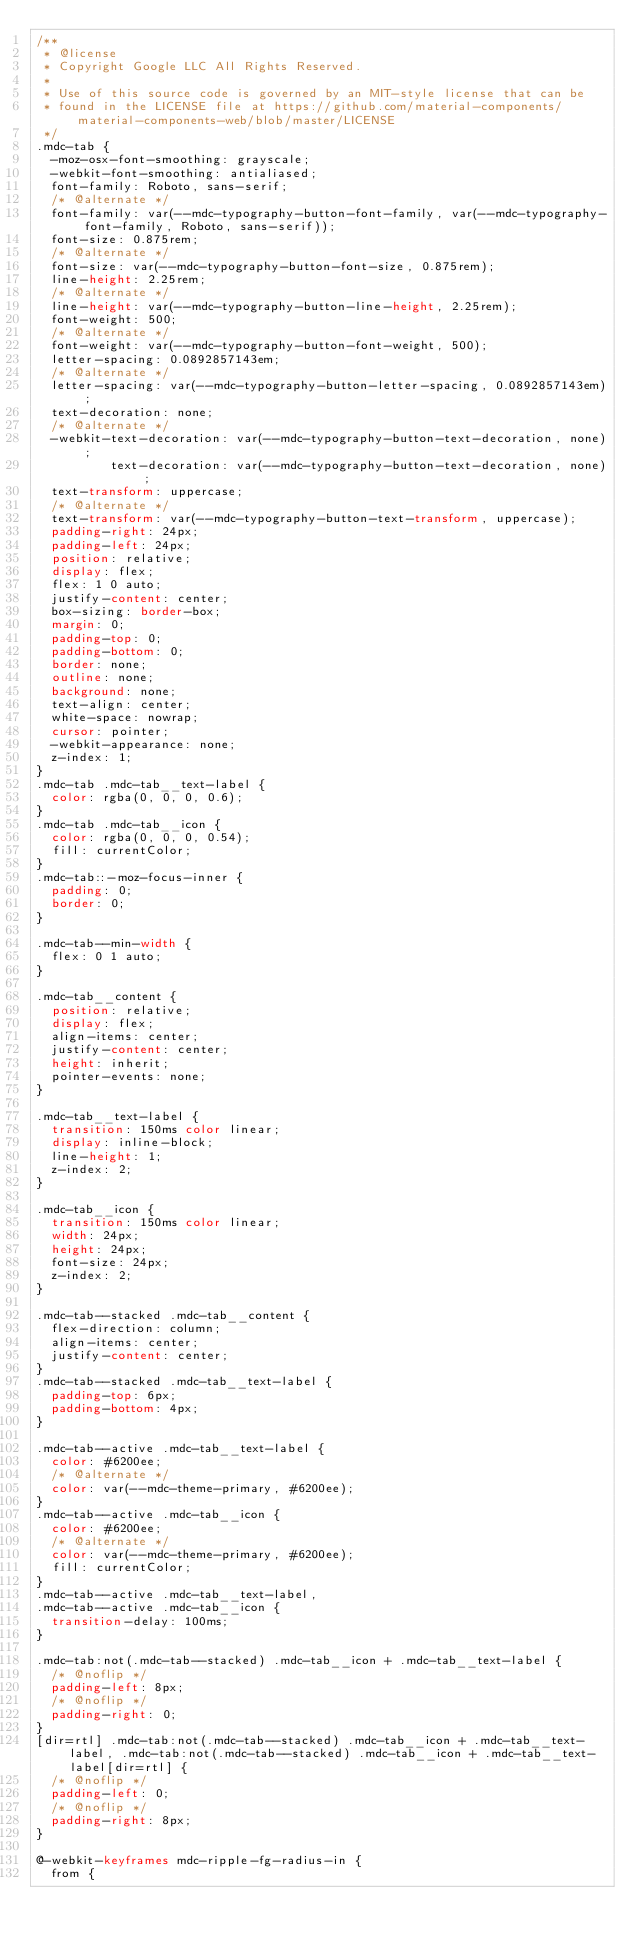<code> <loc_0><loc_0><loc_500><loc_500><_CSS_>/**
 * @license
 * Copyright Google LLC All Rights Reserved.
 *
 * Use of this source code is governed by an MIT-style license that can be
 * found in the LICENSE file at https://github.com/material-components/material-components-web/blob/master/LICENSE
 */
.mdc-tab {
  -moz-osx-font-smoothing: grayscale;
  -webkit-font-smoothing: antialiased;
  font-family: Roboto, sans-serif;
  /* @alternate */
  font-family: var(--mdc-typography-button-font-family, var(--mdc-typography-font-family, Roboto, sans-serif));
  font-size: 0.875rem;
  /* @alternate */
  font-size: var(--mdc-typography-button-font-size, 0.875rem);
  line-height: 2.25rem;
  /* @alternate */
  line-height: var(--mdc-typography-button-line-height, 2.25rem);
  font-weight: 500;
  /* @alternate */
  font-weight: var(--mdc-typography-button-font-weight, 500);
  letter-spacing: 0.0892857143em;
  /* @alternate */
  letter-spacing: var(--mdc-typography-button-letter-spacing, 0.0892857143em);
  text-decoration: none;
  /* @alternate */
  -webkit-text-decoration: var(--mdc-typography-button-text-decoration, none);
          text-decoration: var(--mdc-typography-button-text-decoration, none);
  text-transform: uppercase;
  /* @alternate */
  text-transform: var(--mdc-typography-button-text-transform, uppercase);
  padding-right: 24px;
  padding-left: 24px;
  position: relative;
  display: flex;
  flex: 1 0 auto;
  justify-content: center;
  box-sizing: border-box;
  margin: 0;
  padding-top: 0;
  padding-bottom: 0;
  border: none;
  outline: none;
  background: none;
  text-align: center;
  white-space: nowrap;
  cursor: pointer;
  -webkit-appearance: none;
  z-index: 1;
}
.mdc-tab .mdc-tab__text-label {
  color: rgba(0, 0, 0, 0.6);
}
.mdc-tab .mdc-tab__icon {
  color: rgba(0, 0, 0, 0.54);
  fill: currentColor;
}
.mdc-tab::-moz-focus-inner {
  padding: 0;
  border: 0;
}

.mdc-tab--min-width {
  flex: 0 1 auto;
}

.mdc-tab__content {
  position: relative;
  display: flex;
  align-items: center;
  justify-content: center;
  height: inherit;
  pointer-events: none;
}

.mdc-tab__text-label {
  transition: 150ms color linear;
  display: inline-block;
  line-height: 1;
  z-index: 2;
}

.mdc-tab__icon {
  transition: 150ms color linear;
  width: 24px;
  height: 24px;
  font-size: 24px;
  z-index: 2;
}

.mdc-tab--stacked .mdc-tab__content {
  flex-direction: column;
  align-items: center;
  justify-content: center;
}
.mdc-tab--stacked .mdc-tab__text-label {
  padding-top: 6px;
  padding-bottom: 4px;
}

.mdc-tab--active .mdc-tab__text-label {
  color: #6200ee;
  /* @alternate */
  color: var(--mdc-theme-primary, #6200ee);
}
.mdc-tab--active .mdc-tab__icon {
  color: #6200ee;
  /* @alternate */
  color: var(--mdc-theme-primary, #6200ee);
  fill: currentColor;
}
.mdc-tab--active .mdc-tab__text-label,
.mdc-tab--active .mdc-tab__icon {
  transition-delay: 100ms;
}

.mdc-tab:not(.mdc-tab--stacked) .mdc-tab__icon + .mdc-tab__text-label {
  /* @noflip */
  padding-left: 8px;
  /* @noflip */
  padding-right: 0;
}
[dir=rtl] .mdc-tab:not(.mdc-tab--stacked) .mdc-tab__icon + .mdc-tab__text-label, .mdc-tab:not(.mdc-tab--stacked) .mdc-tab__icon + .mdc-tab__text-label[dir=rtl] {
  /* @noflip */
  padding-left: 0;
  /* @noflip */
  padding-right: 8px;
}

@-webkit-keyframes mdc-ripple-fg-radius-in {
  from {</code> 